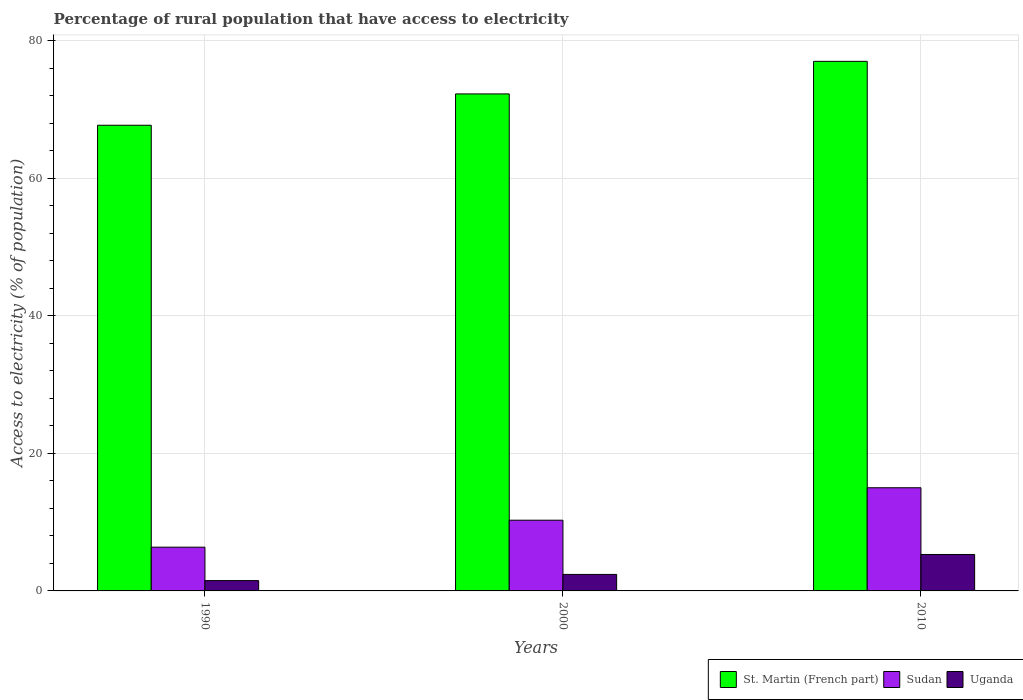How many different coloured bars are there?
Make the answer very short. 3. How many bars are there on the 2nd tick from the left?
Offer a very short reply. 3. What is the label of the 3rd group of bars from the left?
Ensure brevity in your answer.  2010. What is the percentage of rural population that have access to electricity in St. Martin (French part) in 2000?
Offer a terse response. 72.27. Across all years, what is the maximum percentage of rural population that have access to electricity in St. Martin (French part)?
Offer a very short reply. 77. Across all years, what is the minimum percentage of rural population that have access to electricity in St. Martin (French part)?
Your answer should be very brief. 67.71. What is the total percentage of rural population that have access to electricity in Sudan in the graph?
Ensure brevity in your answer.  31.64. What is the difference between the percentage of rural population that have access to electricity in Sudan in 1990 and that in 2010?
Provide a succinct answer. -8.64. What is the difference between the percentage of rural population that have access to electricity in Sudan in 2000 and the percentage of rural population that have access to electricity in Uganda in 1990?
Ensure brevity in your answer.  8.78. What is the average percentage of rural population that have access to electricity in Uganda per year?
Ensure brevity in your answer.  3.07. In the year 1990, what is the difference between the percentage of rural population that have access to electricity in St. Martin (French part) and percentage of rural population that have access to electricity in Sudan?
Provide a short and direct response. 61.35. In how many years, is the percentage of rural population that have access to electricity in Uganda greater than 24 %?
Your response must be concise. 0. What is the ratio of the percentage of rural population that have access to electricity in Sudan in 2000 to that in 2010?
Your response must be concise. 0.69. Is the difference between the percentage of rural population that have access to electricity in St. Martin (French part) in 1990 and 2000 greater than the difference between the percentage of rural population that have access to electricity in Sudan in 1990 and 2000?
Offer a terse response. No. What is the difference between the highest and the second highest percentage of rural population that have access to electricity in Uganda?
Ensure brevity in your answer.  2.9. What is the difference between the highest and the lowest percentage of rural population that have access to electricity in Sudan?
Provide a succinct answer. 8.64. In how many years, is the percentage of rural population that have access to electricity in Uganda greater than the average percentage of rural population that have access to electricity in Uganda taken over all years?
Provide a short and direct response. 1. Is the sum of the percentage of rural population that have access to electricity in Uganda in 1990 and 2000 greater than the maximum percentage of rural population that have access to electricity in Sudan across all years?
Provide a succinct answer. No. What does the 2nd bar from the left in 2010 represents?
Your answer should be compact. Sudan. What does the 1st bar from the right in 2010 represents?
Make the answer very short. Uganda. How many bars are there?
Your response must be concise. 9. Are all the bars in the graph horizontal?
Offer a very short reply. No. How many years are there in the graph?
Offer a terse response. 3. Are the values on the major ticks of Y-axis written in scientific E-notation?
Your answer should be compact. No. How are the legend labels stacked?
Your answer should be compact. Horizontal. What is the title of the graph?
Provide a short and direct response. Percentage of rural population that have access to electricity. What is the label or title of the X-axis?
Your answer should be compact. Years. What is the label or title of the Y-axis?
Ensure brevity in your answer.  Access to electricity (% of population). What is the Access to electricity (% of population) in St. Martin (French part) in 1990?
Your answer should be very brief. 67.71. What is the Access to electricity (% of population) in Sudan in 1990?
Keep it short and to the point. 6.36. What is the Access to electricity (% of population) of St. Martin (French part) in 2000?
Give a very brief answer. 72.27. What is the Access to electricity (% of population) of Sudan in 2000?
Offer a terse response. 10.28. What is the Access to electricity (% of population) of Uganda in 2000?
Your answer should be very brief. 2.4. What is the Access to electricity (% of population) in Sudan in 2010?
Keep it short and to the point. 15. What is the Access to electricity (% of population) in Uganda in 2010?
Offer a terse response. 5.3. Across all years, what is the maximum Access to electricity (% of population) of St. Martin (French part)?
Provide a short and direct response. 77. Across all years, what is the maximum Access to electricity (% of population) of Sudan?
Provide a short and direct response. 15. Across all years, what is the minimum Access to electricity (% of population) in St. Martin (French part)?
Offer a very short reply. 67.71. Across all years, what is the minimum Access to electricity (% of population) in Sudan?
Keep it short and to the point. 6.36. What is the total Access to electricity (% of population) in St. Martin (French part) in the graph?
Offer a terse response. 216.98. What is the total Access to electricity (% of population) in Sudan in the graph?
Make the answer very short. 31.64. What is the total Access to electricity (% of population) of Uganda in the graph?
Offer a terse response. 9.2. What is the difference between the Access to electricity (% of population) of St. Martin (French part) in 1990 and that in 2000?
Offer a very short reply. -4.55. What is the difference between the Access to electricity (% of population) in Sudan in 1990 and that in 2000?
Offer a terse response. -3.92. What is the difference between the Access to electricity (% of population) in Uganda in 1990 and that in 2000?
Keep it short and to the point. -0.9. What is the difference between the Access to electricity (% of population) of St. Martin (French part) in 1990 and that in 2010?
Your answer should be compact. -9.29. What is the difference between the Access to electricity (% of population) of Sudan in 1990 and that in 2010?
Your answer should be very brief. -8.64. What is the difference between the Access to electricity (% of population) of St. Martin (French part) in 2000 and that in 2010?
Provide a succinct answer. -4.74. What is the difference between the Access to electricity (% of population) in Sudan in 2000 and that in 2010?
Keep it short and to the point. -4.72. What is the difference between the Access to electricity (% of population) of St. Martin (French part) in 1990 and the Access to electricity (% of population) of Sudan in 2000?
Ensure brevity in your answer.  57.43. What is the difference between the Access to electricity (% of population) of St. Martin (French part) in 1990 and the Access to electricity (% of population) of Uganda in 2000?
Your answer should be compact. 65.31. What is the difference between the Access to electricity (% of population) of Sudan in 1990 and the Access to electricity (% of population) of Uganda in 2000?
Ensure brevity in your answer.  3.96. What is the difference between the Access to electricity (% of population) in St. Martin (French part) in 1990 and the Access to electricity (% of population) in Sudan in 2010?
Your answer should be compact. 52.71. What is the difference between the Access to electricity (% of population) of St. Martin (French part) in 1990 and the Access to electricity (% of population) of Uganda in 2010?
Your answer should be very brief. 62.41. What is the difference between the Access to electricity (% of population) in Sudan in 1990 and the Access to electricity (% of population) in Uganda in 2010?
Your answer should be very brief. 1.06. What is the difference between the Access to electricity (% of population) of St. Martin (French part) in 2000 and the Access to electricity (% of population) of Sudan in 2010?
Make the answer very short. 57.27. What is the difference between the Access to electricity (% of population) in St. Martin (French part) in 2000 and the Access to electricity (% of population) in Uganda in 2010?
Give a very brief answer. 66.97. What is the difference between the Access to electricity (% of population) of Sudan in 2000 and the Access to electricity (% of population) of Uganda in 2010?
Provide a short and direct response. 4.98. What is the average Access to electricity (% of population) of St. Martin (French part) per year?
Give a very brief answer. 72.33. What is the average Access to electricity (% of population) in Sudan per year?
Offer a terse response. 10.55. What is the average Access to electricity (% of population) in Uganda per year?
Your answer should be compact. 3.07. In the year 1990, what is the difference between the Access to electricity (% of population) of St. Martin (French part) and Access to electricity (% of population) of Sudan?
Ensure brevity in your answer.  61.35. In the year 1990, what is the difference between the Access to electricity (% of population) in St. Martin (French part) and Access to electricity (% of population) in Uganda?
Provide a succinct answer. 66.21. In the year 1990, what is the difference between the Access to electricity (% of population) of Sudan and Access to electricity (% of population) of Uganda?
Make the answer very short. 4.86. In the year 2000, what is the difference between the Access to electricity (% of population) in St. Martin (French part) and Access to electricity (% of population) in Sudan?
Offer a terse response. 61.98. In the year 2000, what is the difference between the Access to electricity (% of population) in St. Martin (French part) and Access to electricity (% of population) in Uganda?
Offer a very short reply. 69.86. In the year 2000, what is the difference between the Access to electricity (% of population) of Sudan and Access to electricity (% of population) of Uganda?
Offer a very short reply. 7.88. In the year 2010, what is the difference between the Access to electricity (% of population) in St. Martin (French part) and Access to electricity (% of population) in Uganda?
Your response must be concise. 71.7. What is the ratio of the Access to electricity (% of population) in St. Martin (French part) in 1990 to that in 2000?
Give a very brief answer. 0.94. What is the ratio of the Access to electricity (% of population) in Sudan in 1990 to that in 2000?
Your response must be concise. 0.62. What is the ratio of the Access to electricity (% of population) in St. Martin (French part) in 1990 to that in 2010?
Your answer should be very brief. 0.88. What is the ratio of the Access to electricity (% of population) in Sudan in 1990 to that in 2010?
Make the answer very short. 0.42. What is the ratio of the Access to electricity (% of population) in Uganda in 1990 to that in 2010?
Make the answer very short. 0.28. What is the ratio of the Access to electricity (% of population) of St. Martin (French part) in 2000 to that in 2010?
Ensure brevity in your answer.  0.94. What is the ratio of the Access to electricity (% of population) of Sudan in 2000 to that in 2010?
Make the answer very short. 0.69. What is the ratio of the Access to electricity (% of population) of Uganda in 2000 to that in 2010?
Offer a terse response. 0.45. What is the difference between the highest and the second highest Access to electricity (% of population) of St. Martin (French part)?
Provide a succinct answer. 4.74. What is the difference between the highest and the second highest Access to electricity (% of population) in Sudan?
Your answer should be very brief. 4.72. What is the difference between the highest and the second highest Access to electricity (% of population) in Uganda?
Ensure brevity in your answer.  2.9. What is the difference between the highest and the lowest Access to electricity (% of population) of St. Martin (French part)?
Your answer should be very brief. 9.29. What is the difference between the highest and the lowest Access to electricity (% of population) of Sudan?
Offer a terse response. 8.64. 